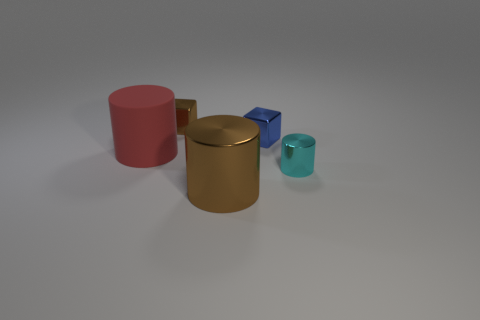Subtract all big metal cylinders. How many cylinders are left? 2 Add 2 large red objects. How many objects exist? 7 Subtract all blue metallic things. Subtract all brown metallic blocks. How many objects are left? 3 Add 2 small blue blocks. How many small blue blocks are left? 3 Add 3 big cyan cylinders. How many big cyan cylinders exist? 3 Subtract all red cylinders. How many cylinders are left? 2 Subtract 0 gray cylinders. How many objects are left? 5 Subtract all blocks. How many objects are left? 3 Subtract 2 cylinders. How many cylinders are left? 1 Subtract all red blocks. Subtract all yellow cylinders. How many blocks are left? 2 